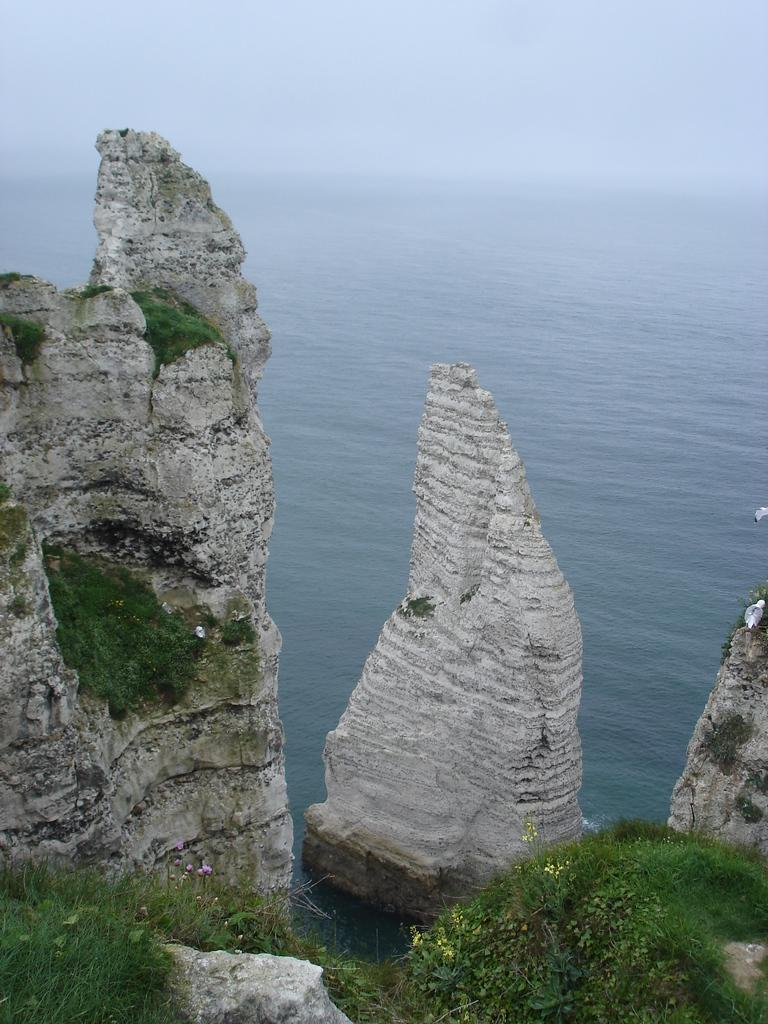What type of vegetation can be seen in the image? There is grass in the image. What other natural elements are present in the image? There are rocks in the image. What can be seen in the distance in the image? Water is visible in the background of the image. What else is visible in the background of the image? The sky is visible in the background of the image. What type of lock is used to secure the angle of the grass in the image? There is no lock or angle mentioned in the image; it simply shows grass, rocks, water, and the sky. 